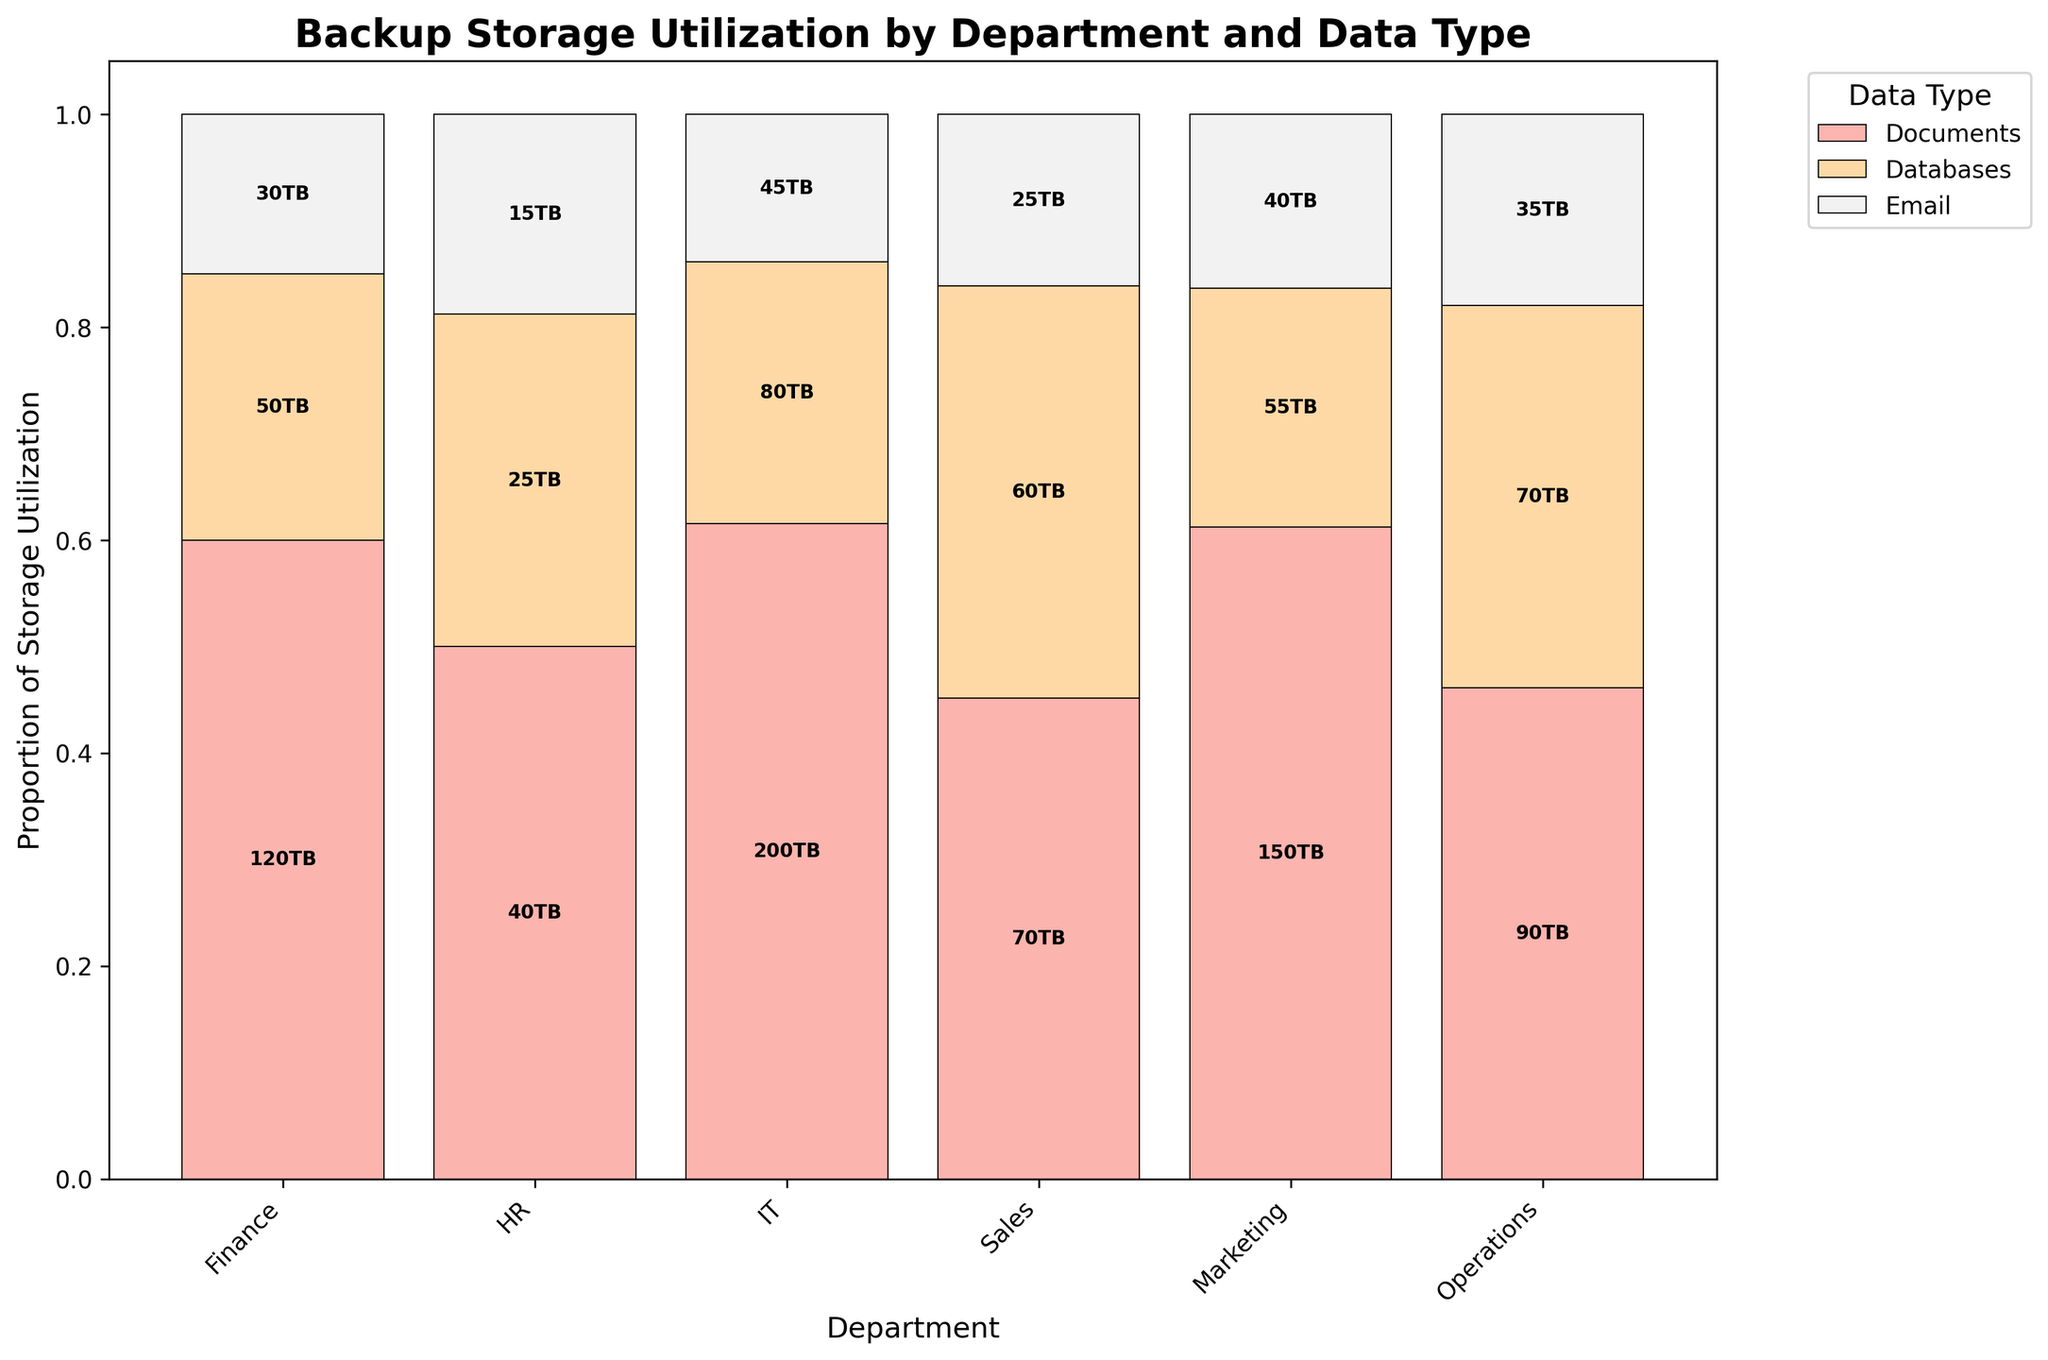What is the title of the plot? The title of the plot is displayed at the top and represents the main summary of the figure. Here, the title summarizes the subject and the variables involved.
Answer: Backup Storage Utilization by Department and Data Type How many departments are represented in the plot? The count of different categories along the x-axis corresponds to the number of departments.
Answer: 6 Which data type uses the highest amount of storage in the IT department? By observing the relative sizes of the colored bars in the IT segment, we can identify which data type has the highest proportion. IT's largest segment is indicated by the color representing 'Databases'.
Answer: Databases Compare the Finance and Sales departments. Which one uses more storage for Documents? To compare, we need to look at the heights of the sections corresponding to 'Documents' for both Finance and Sales. Sales' 'Documents' bar is higher than that of Finance.
Answer: Sales What data type has the smallest storage utilization in the HR department? By examining the HR segment, identify the smallest bar section. The smallest segment is represented by the color for 'Email'.
Answer: Email How much storage does the Operations department use for Databases? Find the 'Databases' section within the Operations department. The data label in that section shows the storage value in terabytes.
Answer: 150TB Which department has the highest overall storage utilization for Databases? Evaluate the sum of the heights of the 'Databases' sections across all departments and determine which is the largest. IT’s 'Databases' section is the highest.
Answer: IT What is the total storage utilization for Email across all departments? Sum the storage values from all 'Email' sections. (30 + 15 + 45 + 35 + 25 + 40) = 190TB.
Answer: 190TB What is the difference in storage utilization for Documents between the IT and Finance departments? Subtract the storage value of Finance's 'Documents' section from the IT's 'Documents' section. IT (80TB) - Finance (50TB) = 30TB.
Answer: 30TB 